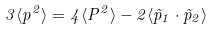Convert formula to latex. <formula><loc_0><loc_0><loc_500><loc_500>3 \langle p ^ { 2 } \rangle = 4 \langle P ^ { 2 } \rangle - 2 \langle \vec { p } _ { 1 } \cdot \vec { p } _ { 2 } \rangle \\</formula> 